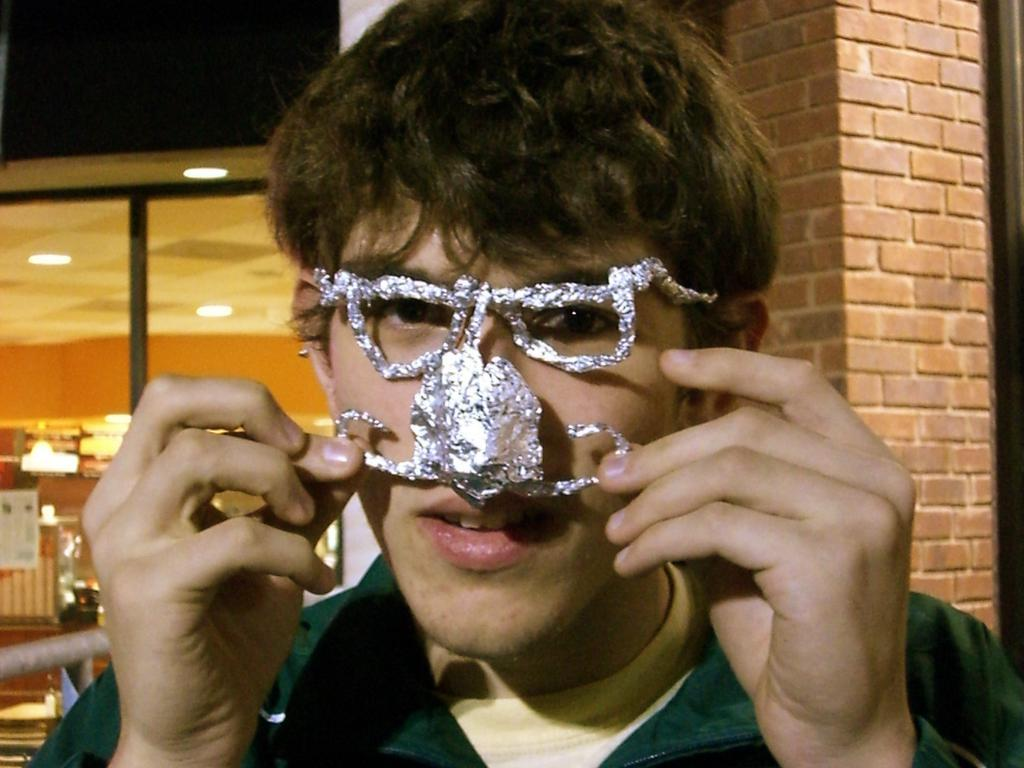What is the man wearing in the image? The man is wearing clothes in the image. How close is the camera to the man in the image? The man is in a close-up image. How would you describe the style of the image? The image is described as creative. What is behind the man in the image? There is a brick wall and a glass window behind the man in the image. What can be seen in the image that might provide illumination? There are lights visible in the image. How many clocks are hanging on the brick wall behind the man? There are no clocks visible on the brick wall behind the man in the image. What type of bead is being used to create the lights in the image? There is no bead present in the image; the lights are not described in terms of their construction. 